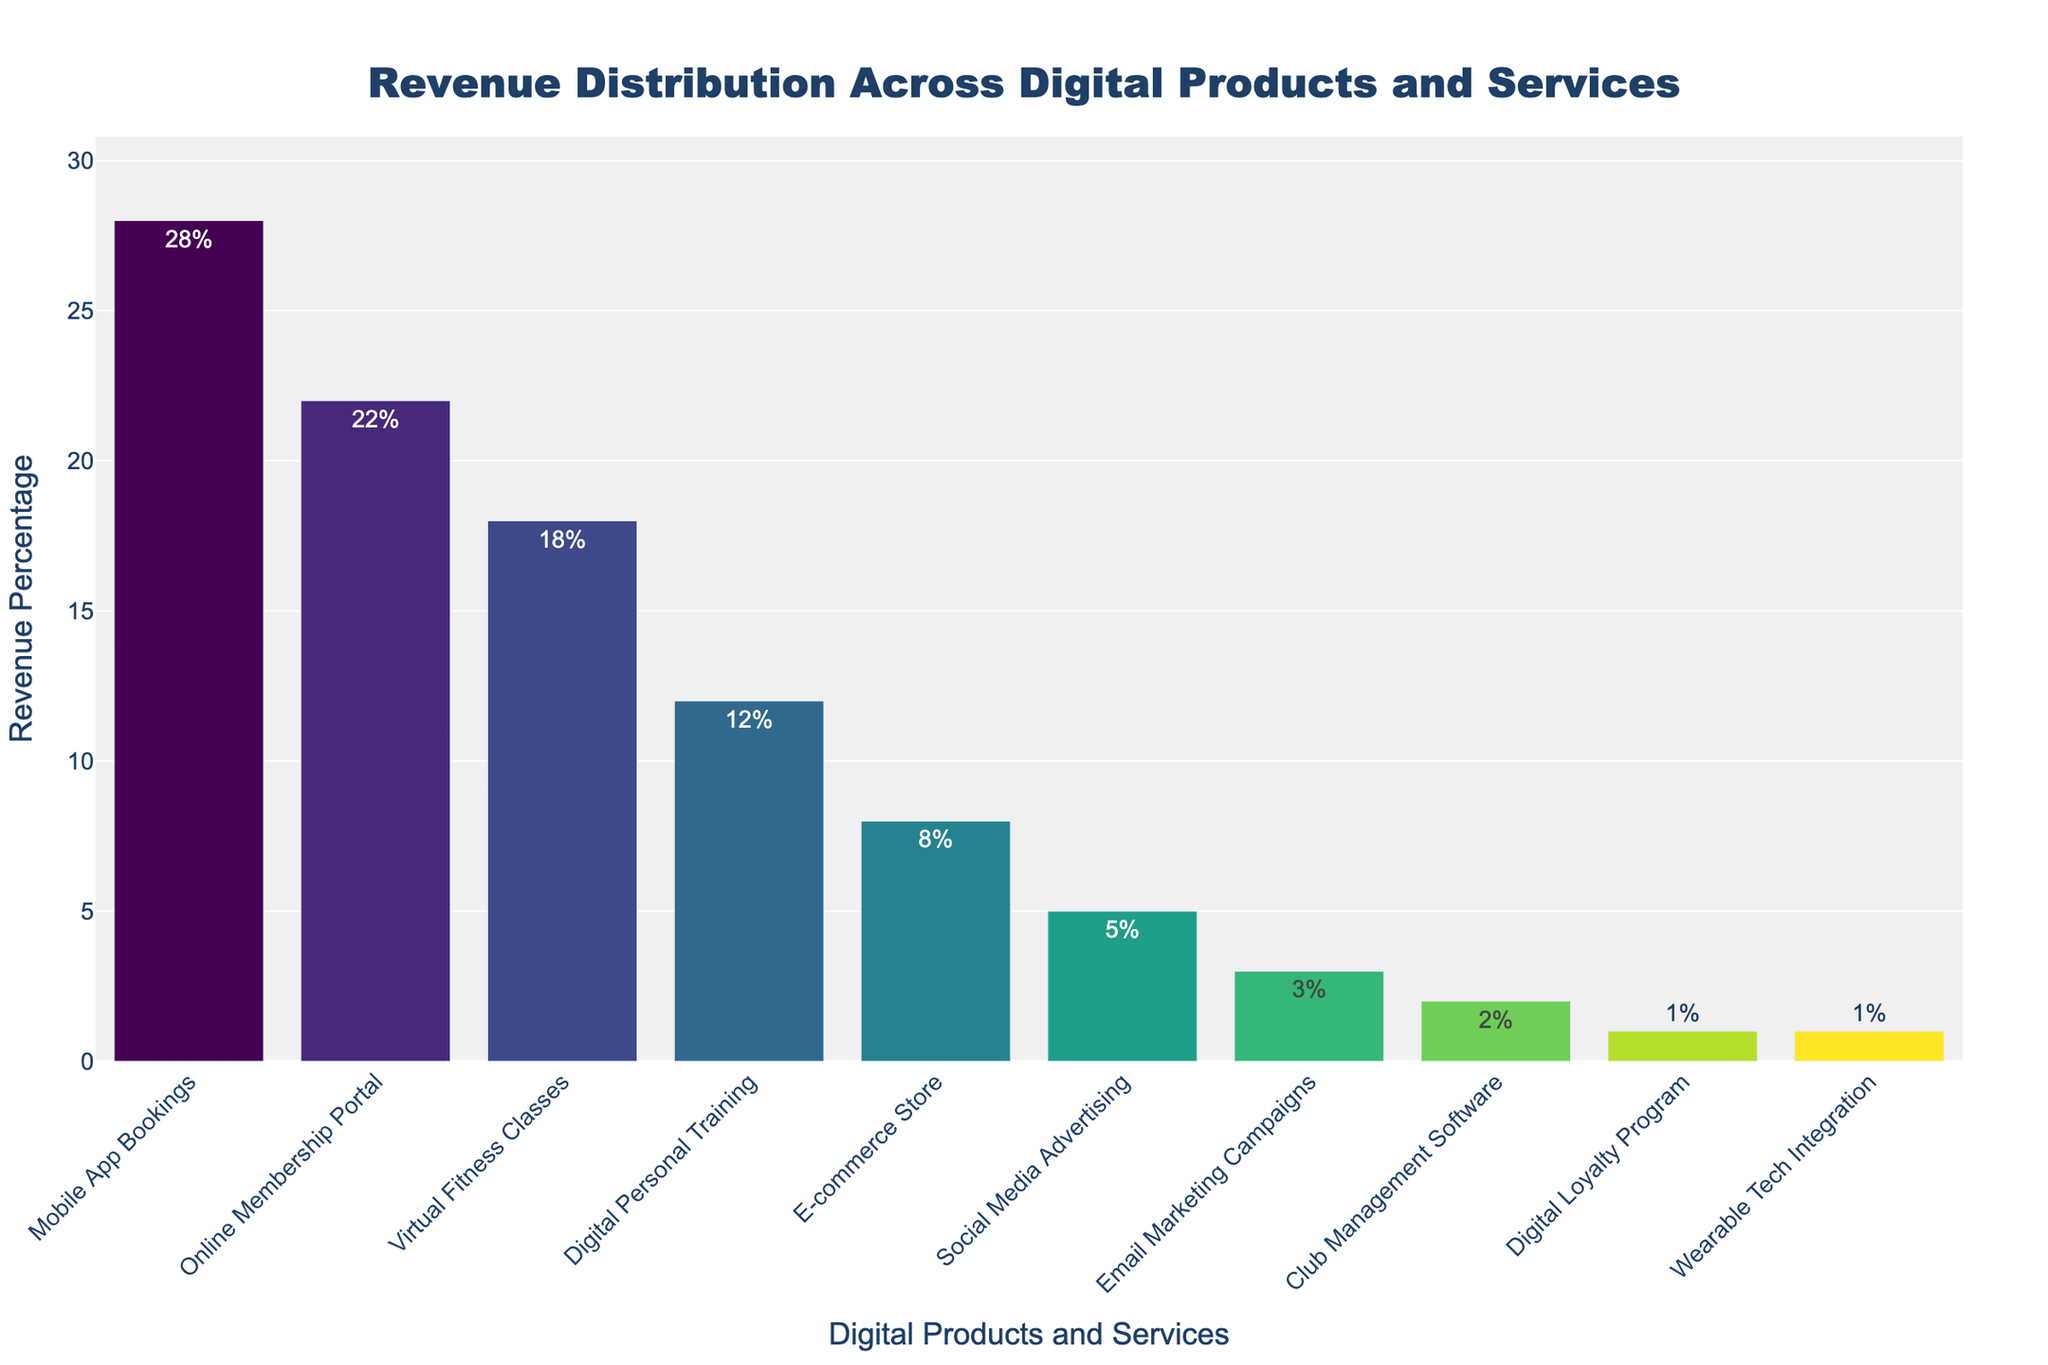What is the total revenue percentage for Mobile App Bookings and Online Membership Portal? Mobile App Bookings contributes 28% and Online Membership Portal contributes 22%. Adding these together, 28% + 22% = 50%.
Answer: 50% Which product has the lowest revenue percentage? By examining the chart, both Digital Loyalty Program and Wearable Tech Integration have the lowest revenue percentage at 1%.
Answer: Digital Loyalty Program, Wearable Tech Integration Is the revenue percentage for Virtual Fitness Classes higher than Digital Personal Training? Yes, Virtual Fitness Classes have a revenue percentage of 18%, and Digital Personal Training has a revenue percentage of 12%. Since 18% > 12%, Virtual Fitness Classes have a higher revenue percentage.
Answer: Yes What is the difference in revenue percentage between Mobile App Bookings and the E-commerce Store? Mobile App Bookings has a revenue percentage of 28%, and the E-commerce Store has a revenue percentage of 8%. The difference is 28% - 8% = 20%.
Answer: 20% Which product generates the highest revenue percentage? Mobile App Bookings has the highest revenue percentage at 28%, as shown by the tallest bar in the chart.
Answer: Mobile App Bookings What is the sum of the revenue percentages for Virtual Fitness Classes, Social Media Advertising, and Email Marketing Campaigns? Virtual Fitness Classes contribute 18%, Social Media Advertising contributes 5%, and Email Marketing Campaigns contribute 3%. Adding these together: 18% + 5% + 3% = 26%.
Answer: 26% Which two products generate equal revenue percentages and what is the percentage? Both Club Management Software and Digital Loyalty Program generate equal revenue percentages of 1%, as indicated by the equal height of their bars.
Answer: Club Management Software, Digital Loyalty Program, 1% How many products have a revenue percentage greater than 10%? By scanning the chart, Mobile App Bookings, Online Membership Portal, Virtual Fitness Classes, and Digital Personal Training all have revenue percentages greater than 10%. There are 4 products in total.
Answer: 4 What is the average revenue percentage for the least three contributing products? The least three contributing products are Digital Loyalty Program (1%), Wearable Tech Integration (1%), and Club Management Software (2%). The average is (1% + 1% + 2%) / 3 = 4% / 3 ≈ 1.33%.
Answer: 1.33% Compare the revenue percentages of Email Marketing Campaigns and Club Management Software. Which one contributes more and by how much? Email Marketing Campaigns has a revenue percentage of 3%, and Club Management Software has 2%. Therefore, Email Marketing Campaigns contributes more by 3% - 2% = 1%.
Answer: Email Marketing Campaigns, 1% 